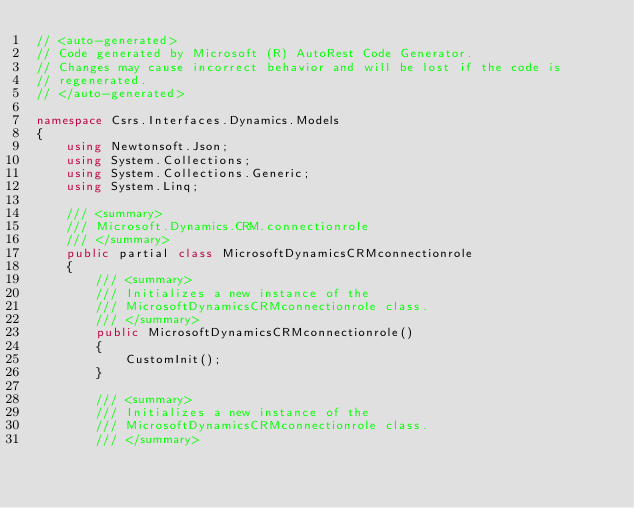<code> <loc_0><loc_0><loc_500><loc_500><_C#_>// <auto-generated>
// Code generated by Microsoft (R) AutoRest Code Generator.
// Changes may cause incorrect behavior and will be lost if the code is
// regenerated.
// </auto-generated>

namespace Csrs.Interfaces.Dynamics.Models
{
    using Newtonsoft.Json;
    using System.Collections;
    using System.Collections.Generic;
    using System.Linq;

    /// <summary>
    /// Microsoft.Dynamics.CRM.connectionrole
    /// </summary>
    public partial class MicrosoftDynamicsCRMconnectionrole
    {
        /// <summary>
        /// Initializes a new instance of the
        /// MicrosoftDynamicsCRMconnectionrole class.
        /// </summary>
        public MicrosoftDynamicsCRMconnectionrole()
        {
            CustomInit();
        }

        /// <summary>
        /// Initializes a new instance of the
        /// MicrosoftDynamicsCRMconnectionrole class.
        /// </summary></code> 